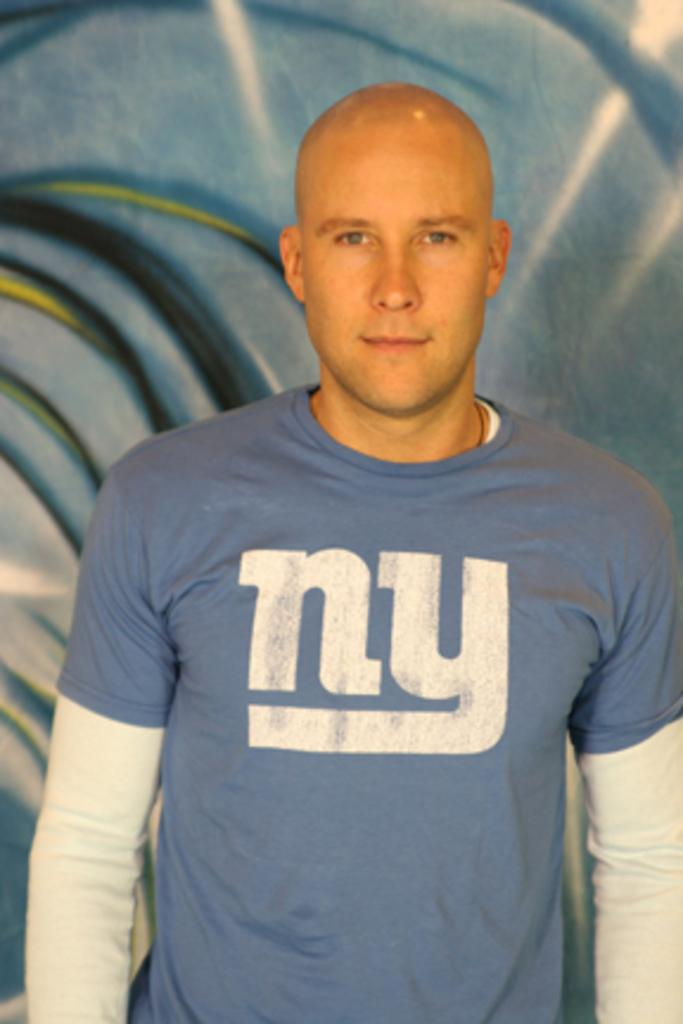Who or what is the main subject of the image? There is a person in the image. What is the person wearing? The person is wearing a blue T-shirt. What is the person doing in the image? The person is standing. What color is the background of the image? The background of the image is blue. What type of squirrel can be seen climbing the person's face in the image? There is no squirrel present in the image, and the person's face is not visible. 